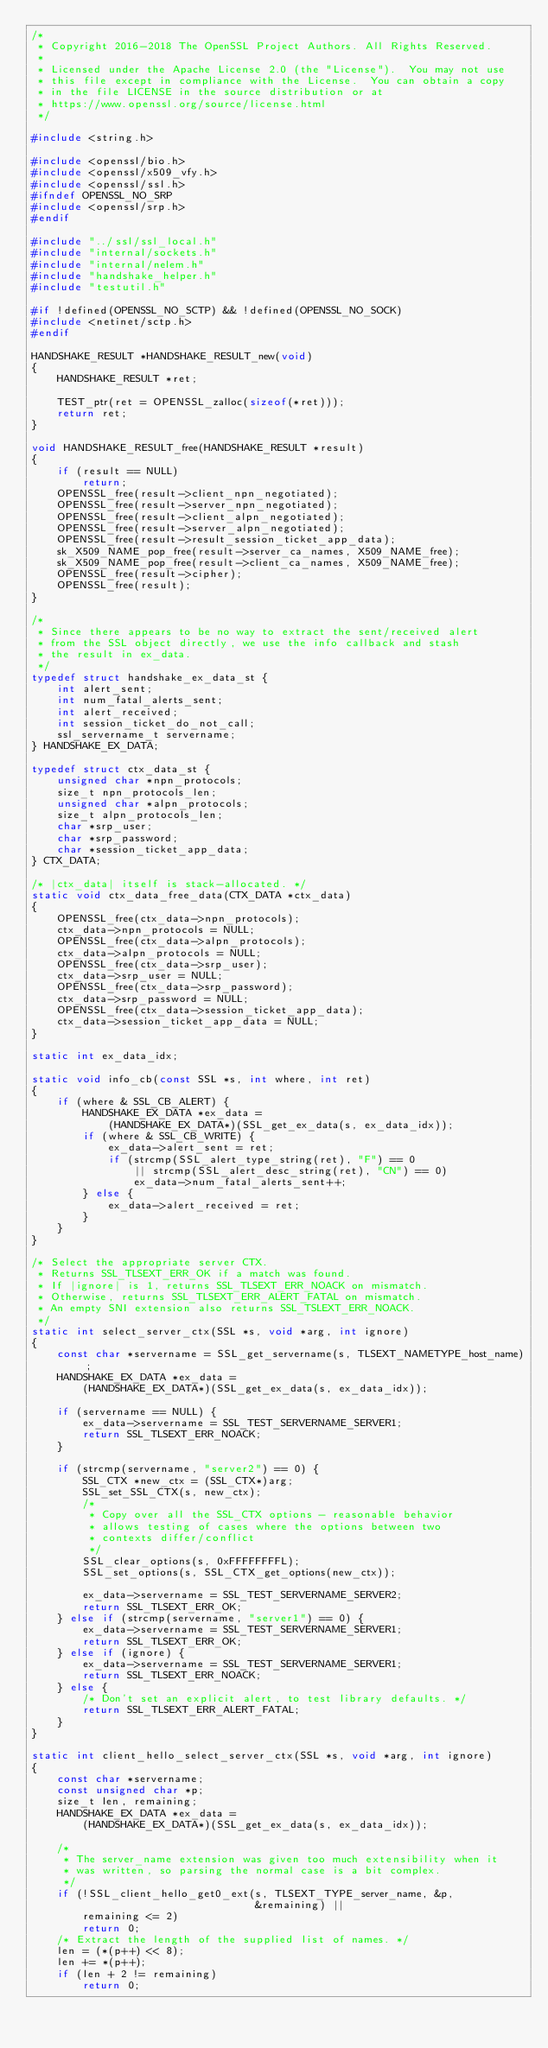<code> <loc_0><loc_0><loc_500><loc_500><_C_>/*
 * Copyright 2016-2018 The OpenSSL Project Authors. All Rights Reserved.
 *
 * Licensed under the Apache License 2.0 (the "License").  You may not use
 * this file except in compliance with the License.  You can obtain a copy
 * in the file LICENSE in the source distribution or at
 * https://www.openssl.org/source/license.html
 */

#include <string.h>

#include <openssl/bio.h>
#include <openssl/x509_vfy.h>
#include <openssl/ssl.h>
#ifndef OPENSSL_NO_SRP
#include <openssl/srp.h>
#endif

#include "../ssl/ssl_local.h"
#include "internal/sockets.h"
#include "internal/nelem.h"
#include "handshake_helper.h"
#include "testutil.h"

#if !defined(OPENSSL_NO_SCTP) && !defined(OPENSSL_NO_SOCK)
#include <netinet/sctp.h>
#endif

HANDSHAKE_RESULT *HANDSHAKE_RESULT_new(void)
{
    HANDSHAKE_RESULT *ret;

    TEST_ptr(ret = OPENSSL_zalloc(sizeof(*ret)));
    return ret;
}

void HANDSHAKE_RESULT_free(HANDSHAKE_RESULT *result)
{
    if (result == NULL)
        return;
    OPENSSL_free(result->client_npn_negotiated);
    OPENSSL_free(result->server_npn_negotiated);
    OPENSSL_free(result->client_alpn_negotiated);
    OPENSSL_free(result->server_alpn_negotiated);
    OPENSSL_free(result->result_session_ticket_app_data);
    sk_X509_NAME_pop_free(result->server_ca_names, X509_NAME_free);
    sk_X509_NAME_pop_free(result->client_ca_names, X509_NAME_free);
    OPENSSL_free(result->cipher);
    OPENSSL_free(result);
}

/*
 * Since there appears to be no way to extract the sent/received alert
 * from the SSL object directly, we use the info callback and stash
 * the result in ex_data.
 */
typedef struct handshake_ex_data_st {
    int alert_sent;
    int num_fatal_alerts_sent;
    int alert_received;
    int session_ticket_do_not_call;
    ssl_servername_t servername;
} HANDSHAKE_EX_DATA;

typedef struct ctx_data_st {
    unsigned char *npn_protocols;
    size_t npn_protocols_len;
    unsigned char *alpn_protocols;
    size_t alpn_protocols_len;
    char *srp_user;
    char *srp_password;
    char *session_ticket_app_data;
} CTX_DATA;

/* |ctx_data| itself is stack-allocated. */
static void ctx_data_free_data(CTX_DATA *ctx_data)
{
    OPENSSL_free(ctx_data->npn_protocols);
    ctx_data->npn_protocols = NULL;
    OPENSSL_free(ctx_data->alpn_protocols);
    ctx_data->alpn_protocols = NULL;
    OPENSSL_free(ctx_data->srp_user);
    ctx_data->srp_user = NULL;
    OPENSSL_free(ctx_data->srp_password);
    ctx_data->srp_password = NULL;
    OPENSSL_free(ctx_data->session_ticket_app_data);
    ctx_data->session_ticket_app_data = NULL;
}

static int ex_data_idx;

static void info_cb(const SSL *s, int where, int ret)
{
    if (where & SSL_CB_ALERT) {
        HANDSHAKE_EX_DATA *ex_data =
            (HANDSHAKE_EX_DATA*)(SSL_get_ex_data(s, ex_data_idx));
        if (where & SSL_CB_WRITE) {
            ex_data->alert_sent = ret;
            if (strcmp(SSL_alert_type_string(ret), "F") == 0
                || strcmp(SSL_alert_desc_string(ret), "CN") == 0)
                ex_data->num_fatal_alerts_sent++;
        } else {
            ex_data->alert_received = ret;
        }
    }
}

/* Select the appropriate server CTX.
 * Returns SSL_TLSEXT_ERR_OK if a match was found.
 * If |ignore| is 1, returns SSL_TLSEXT_ERR_NOACK on mismatch.
 * Otherwise, returns SSL_TLSEXT_ERR_ALERT_FATAL on mismatch.
 * An empty SNI extension also returns SSL_TSLEXT_ERR_NOACK.
 */
static int select_server_ctx(SSL *s, void *arg, int ignore)
{
    const char *servername = SSL_get_servername(s, TLSEXT_NAMETYPE_host_name);
    HANDSHAKE_EX_DATA *ex_data =
        (HANDSHAKE_EX_DATA*)(SSL_get_ex_data(s, ex_data_idx));

    if (servername == NULL) {
        ex_data->servername = SSL_TEST_SERVERNAME_SERVER1;
        return SSL_TLSEXT_ERR_NOACK;
    }

    if (strcmp(servername, "server2") == 0) {
        SSL_CTX *new_ctx = (SSL_CTX*)arg;
        SSL_set_SSL_CTX(s, new_ctx);
        /*
         * Copy over all the SSL_CTX options - reasonable behavior
         * allows testing of cases where the options between two
         * contexts differ/conflict
         */
        SSL_clear_options(s, 0xFFFFFFFFL);
        SSL_set_options(s, SSL_CTX_get_options(new_ctx));

        ex_data->servername = SSL_TEST_SERVERNAME_SERVER2;
        return SSL_TLSEXT_ERR_OK;
    } else if (strcmp(servername, "server1") == 0) {
        ex_data->servername = SSL_TEST_SERVERNAME_SERVER1;
        return SSL_TLSEXT_ERR_OK;
    } else if (ignore) {
        ex_data->servername = SSL_TEST_SERVERNAME_SERVER1;
        return SSL_TLSEXT_ERR_NOACK;
    } else {
        /* Don't set an explicit alert, to test library defaults. */
        return SSL_TLSEXT_ERR_ALERT_FATAL;
    }
}

static int client_hello_select_server_ctx(SSL *s, void *arg, int ignore)
{
    const char *servername;
    const unsigned char *p;
    size_t len, remaining;
    HANDSHAKE_EX_DATA *ex_data =
        (HANDSHAKE_EX_DATA*)(SSL_get_ex_data(s, ex_data_idx));

    /*
     * The server_name extension was given too much extensibility when it
     * was written, so parsing the normal case is a bit complex.
     */
    if (!SSL_client_hello_get0_ext(s, TLSEXT_TYPE_server_name, &p,
                                   &remaining) ||
        remaining <= 2)
        return 0;
    /* Extract the length of the supplied list of names. */
    len = (*(p++) << 8);
    len += *(p++);
    if (len + 2 != remaining)
        return 0;</code> 